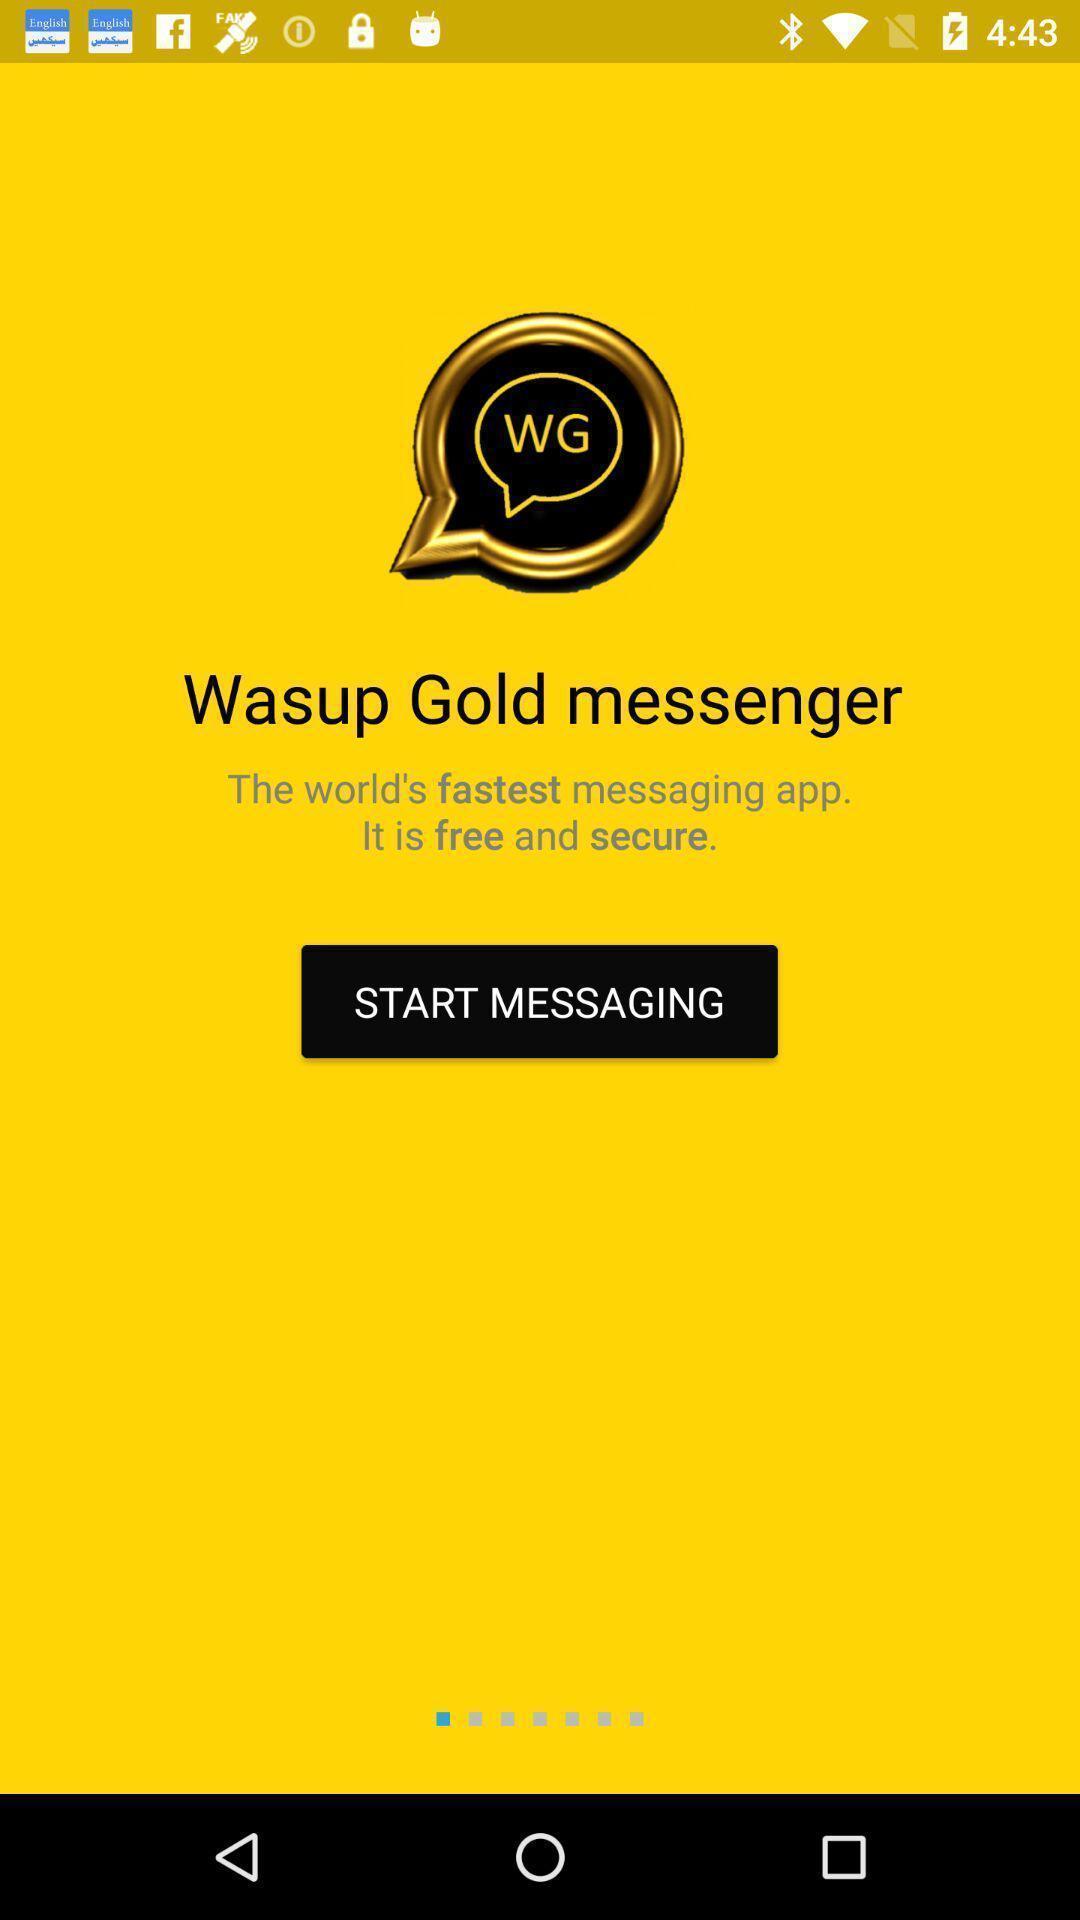Describe the visual elements of this screenshot. Welcome page of a social app. 